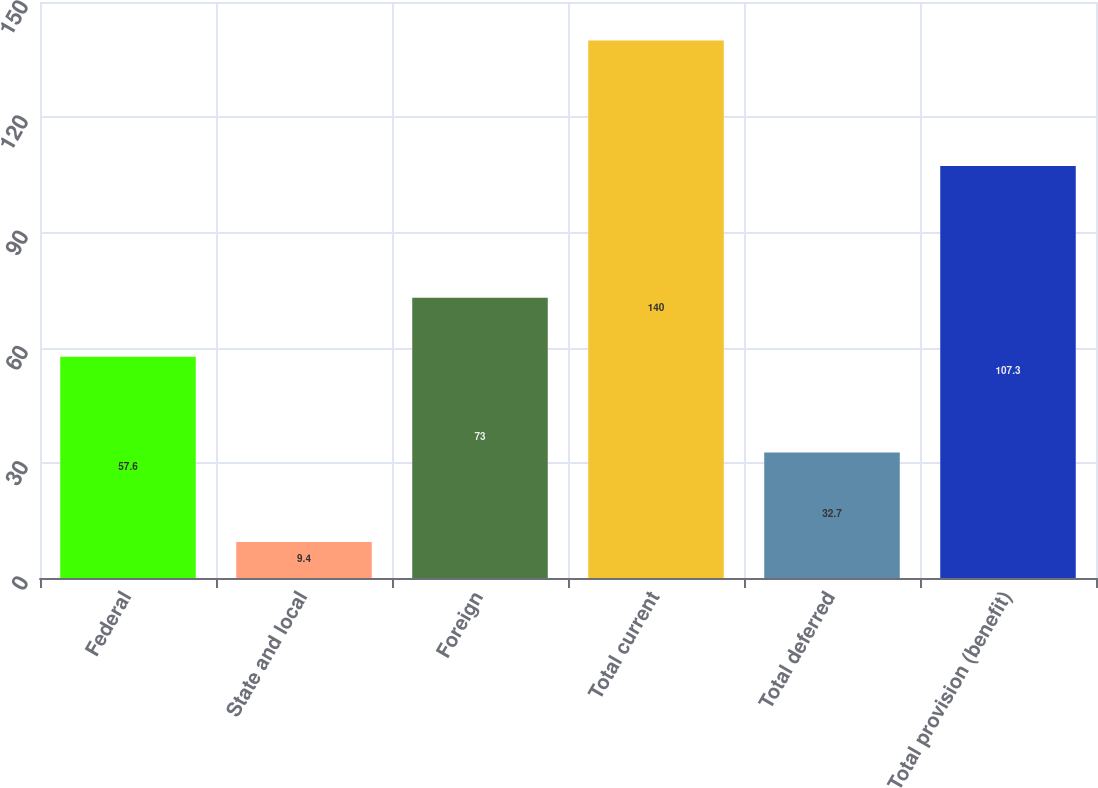Convert chart. <chart><loc_0><loc_0><loc_500><loc_500><bar_chart><fcel>Federal<fcel>State and local<fcel>Foreign<fcel>Total current<fcel>Total deferred<fcel>Total provision (benefit)<nl><fcel>57.6<fcel>9.4<fcel>73<fcel>140<fcel>32.7<fcel>107.3<nl></chart> 